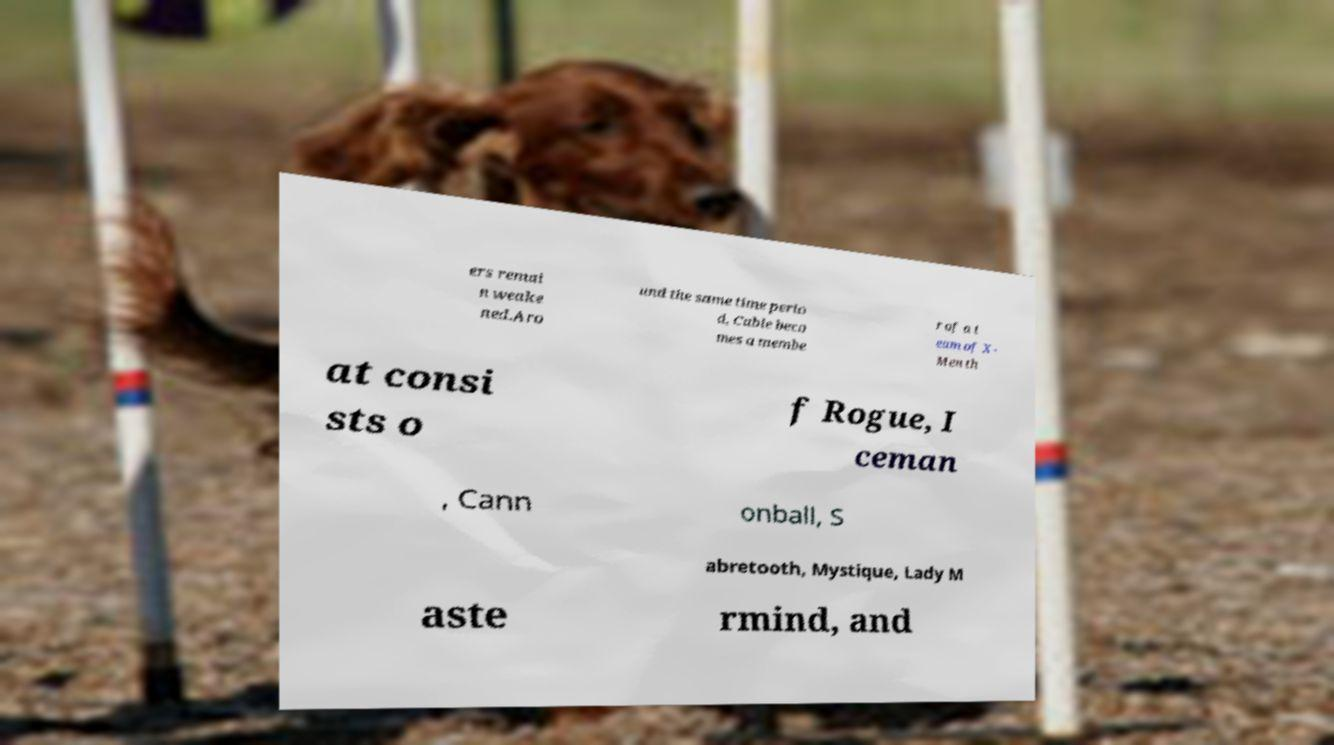I need the written content from this picture converted into text. Can you do that? ers remai n weake ned.Aro und the same time perio d, Cable beco mes a membe r of a t eam of X- Men th at consi sts o f Rogue, I ceman , Cann onball, S abretooth, Mystique, Lady M aste rmind, and 